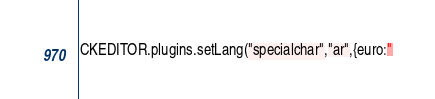<code> <loc_0><loc_0><loc_500><loc_500><_JavaScript_>CKEDITOR.plugins.setLang("specialchar","ar",{euro:"</code> 